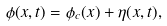<formula> <loc_0><loc_0><loc_500><loc_500>\phi ( x , t ) = \phi _ { c } ( x ) + \eta ( x , t ) ,</formula> 